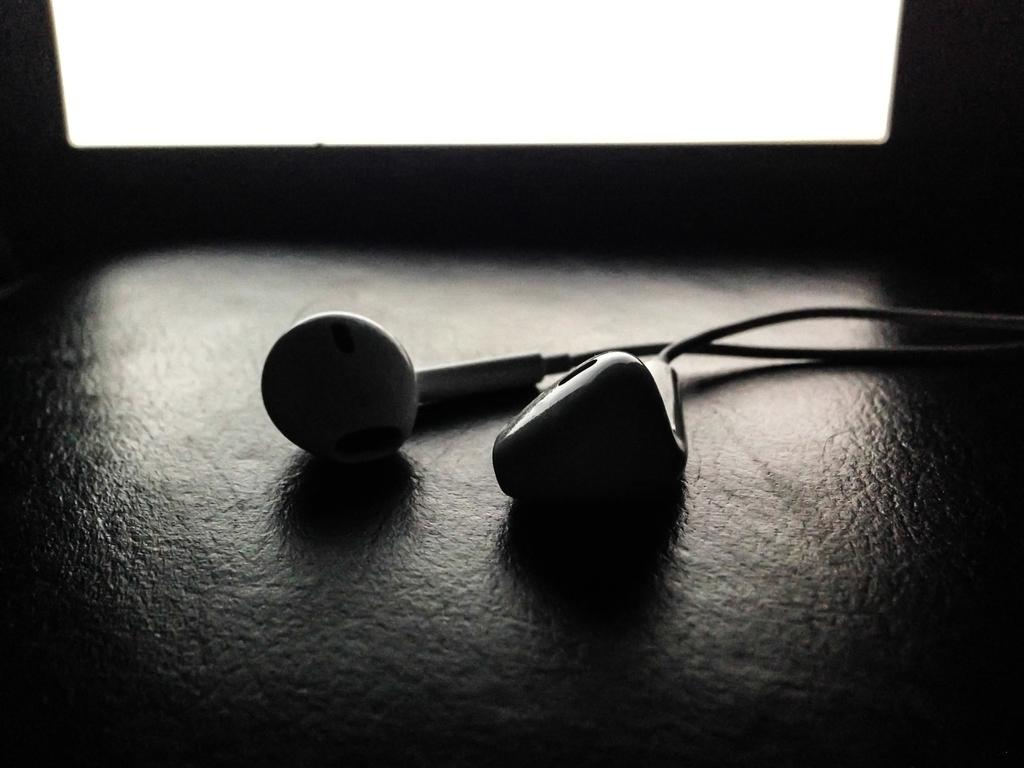What is the color scheme of the image? The image is black and white. What can be seen in the middle of the image? There are headphones in the middle of the image. What type of education does the expert in the image have? There is no expert present in the image, as it only features headphones. Can you tell me how many zippers are visible in the image? There are no zippers present in the image. 